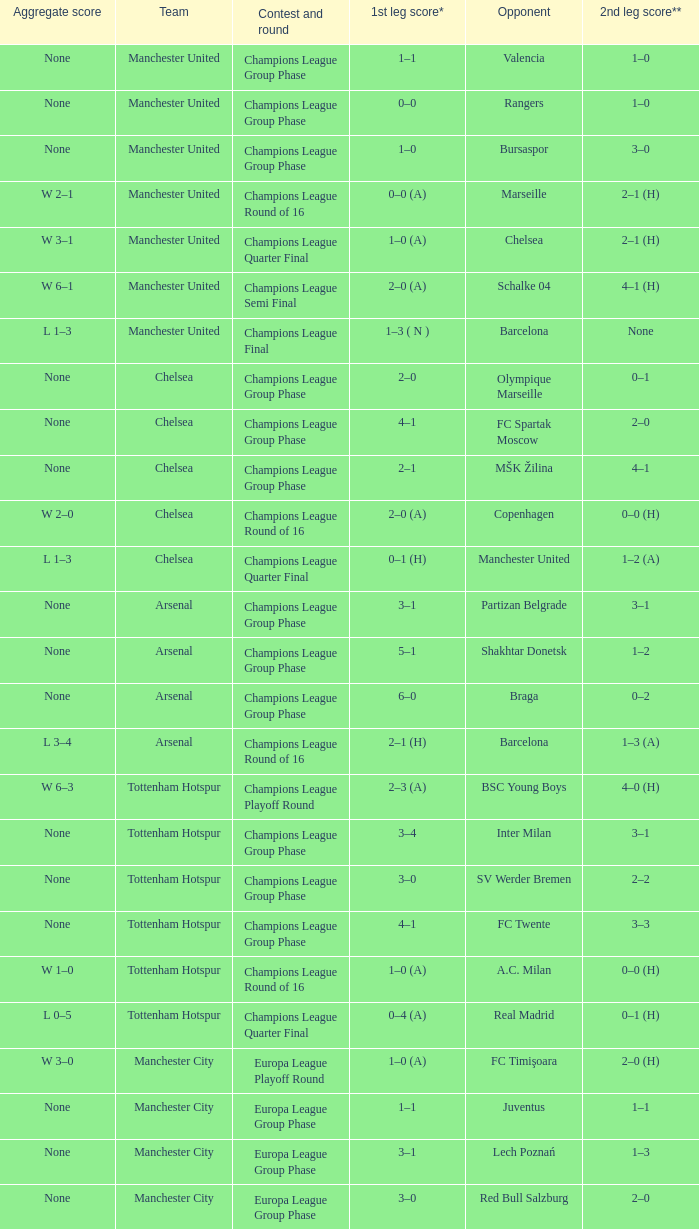How many goals did each team score in the first leg of the match between Liverpool and Steaua Bucureşti? 4–1. 